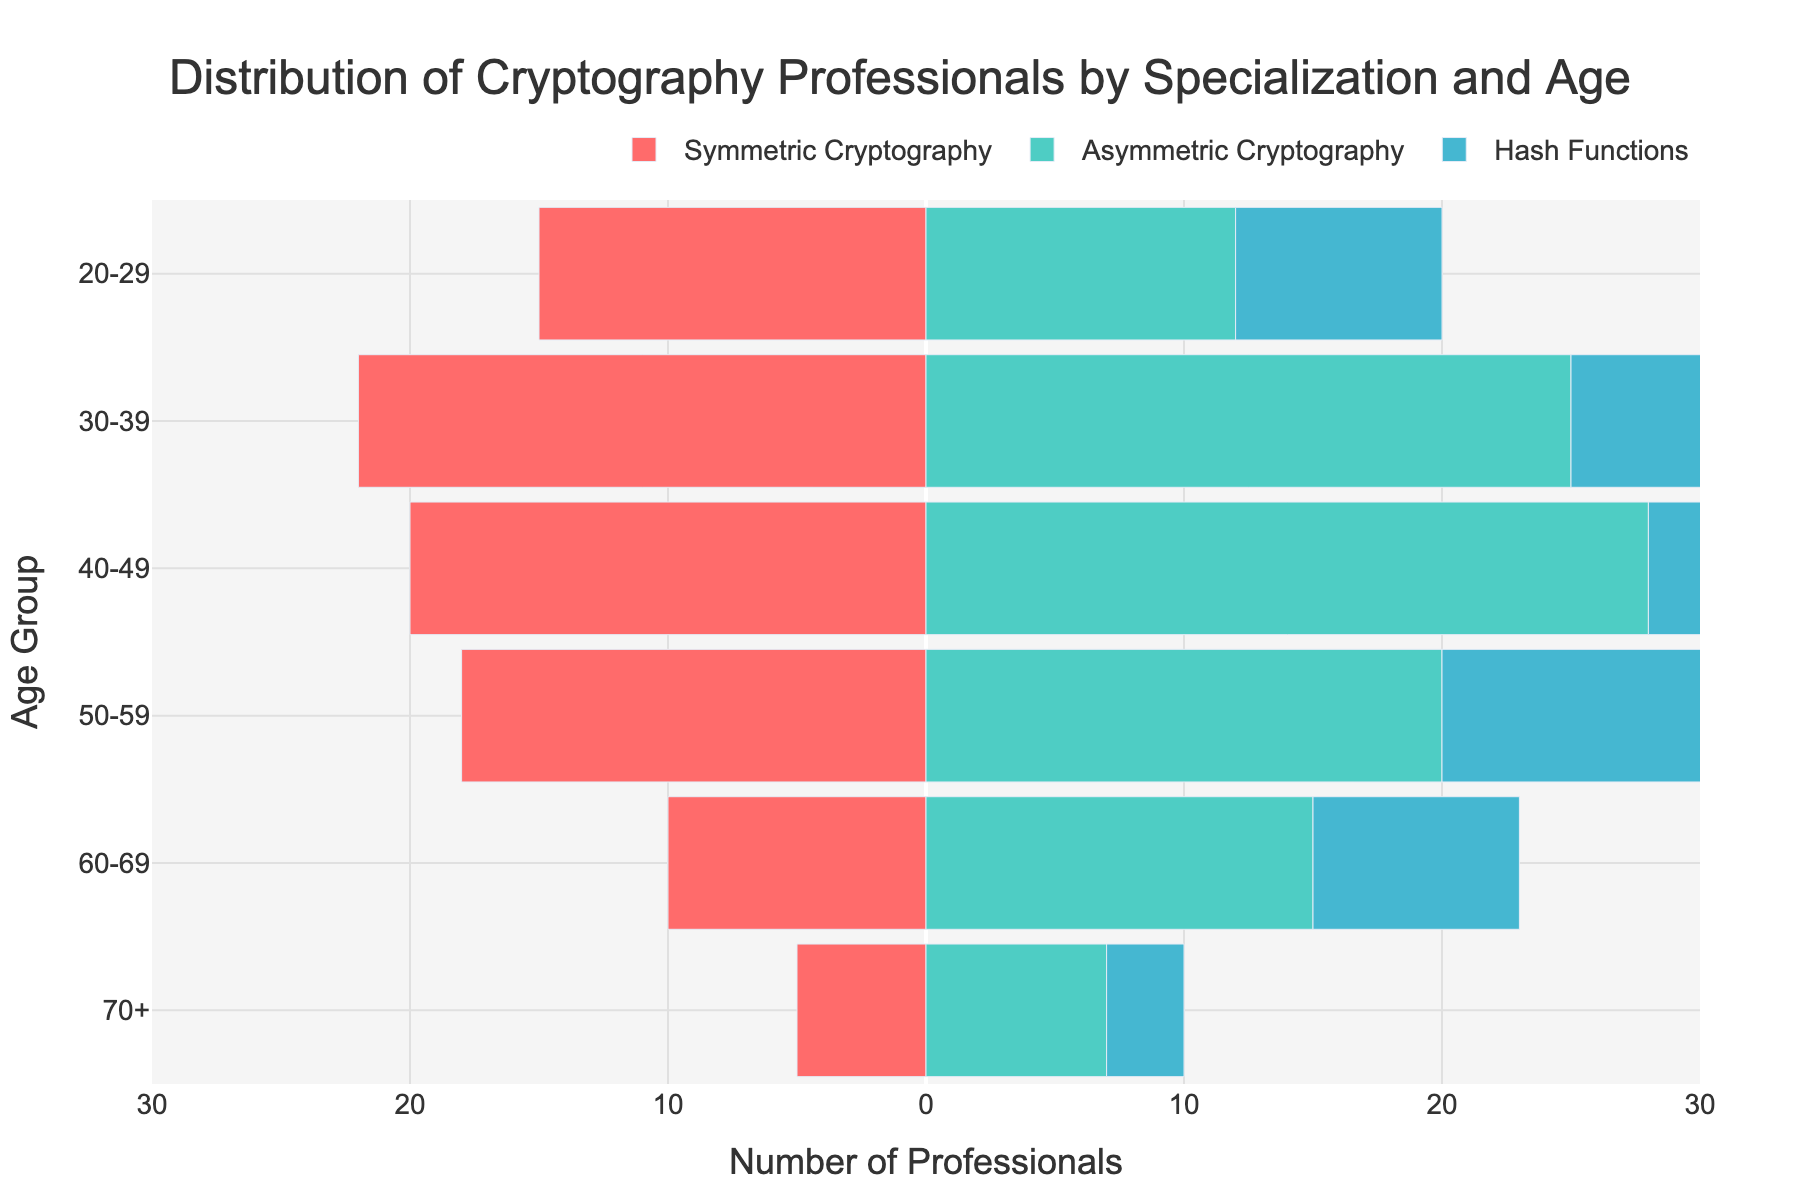What's the title of the figure? The title is displayed at the top center of the figure, indicating the subject of the chart. The text directly points out that it's about the distribution of cryptography professionals.
Answer: Distribution of Cryptography Professionals by Specialization and Age What is the color representing 'Symmetric Cryptography'? The color of the 'Symmetric Cryptography' bar is distinguishable and appears as a pinkish/red shade within the chart's legend.
Answer: Pink/Red Which age group has the highest number of professionals in 'Asymmetric Cryptography'? To find this, look at the values of the 'Asymmetric Cryptography' bars. The '30-39' age group has the longest bar for this group, indicating the highest number.
Answer: 30-39 How many professionals in total are represented in the 'Hash Functions' category? Add the counts from 'Hash Functions' across all age groups: 8 (20-29) + 18 (30-39) + 15 (40-49) + 12 (50-59) + 8 (60-69) + 3 (70+). Summing these gives a total number.
Answer: 64 What is the least common specialization among the '20-29' age group? Compare the counts within the '20-29' age group. 'Hash Functions' has 8 professionals, which is the least among the three categories.
Answer: Hash Functions In the '50-59' age group, is there a greater number of 'Symmetric Cryptography' or 'Asymmetric Cryptography' professionals? Compare the lengths of the bars for these specializations in the '50-59' age group. 'Symmetric Cryptography' has 18, while 'Asymmetric Cryptography' has 20 professionals.
Answer: Asymmetric Cryptography What's the difference between the number of 'Symmetric Cryptography' professionals in the '30-39' and '60-69' age groups? Subtract the number of 'Symmetric Cryptography' professionals in '60-69' from those in '30-39'. 22 (30-39) - 10 (60-69) gives the difference.
Answer: 12 Which specialization has the longest bar in the '70+' age group? Observe the lengths of the bars in the '70+' age group. 'Symmetric Cryptography' has the longest bar with 5 professionals.
Answer: Symmetric Cryptography In which age group is the total number of cryptography professionals the highest? Sum the values for each specialization within each age group, and compare totals for all groups. For instance, (20-29: 15+12+8)=35, (30-39: 22+25+18)=65, etc. The '30-39' age group has the highest total.
Answer: 30-39 